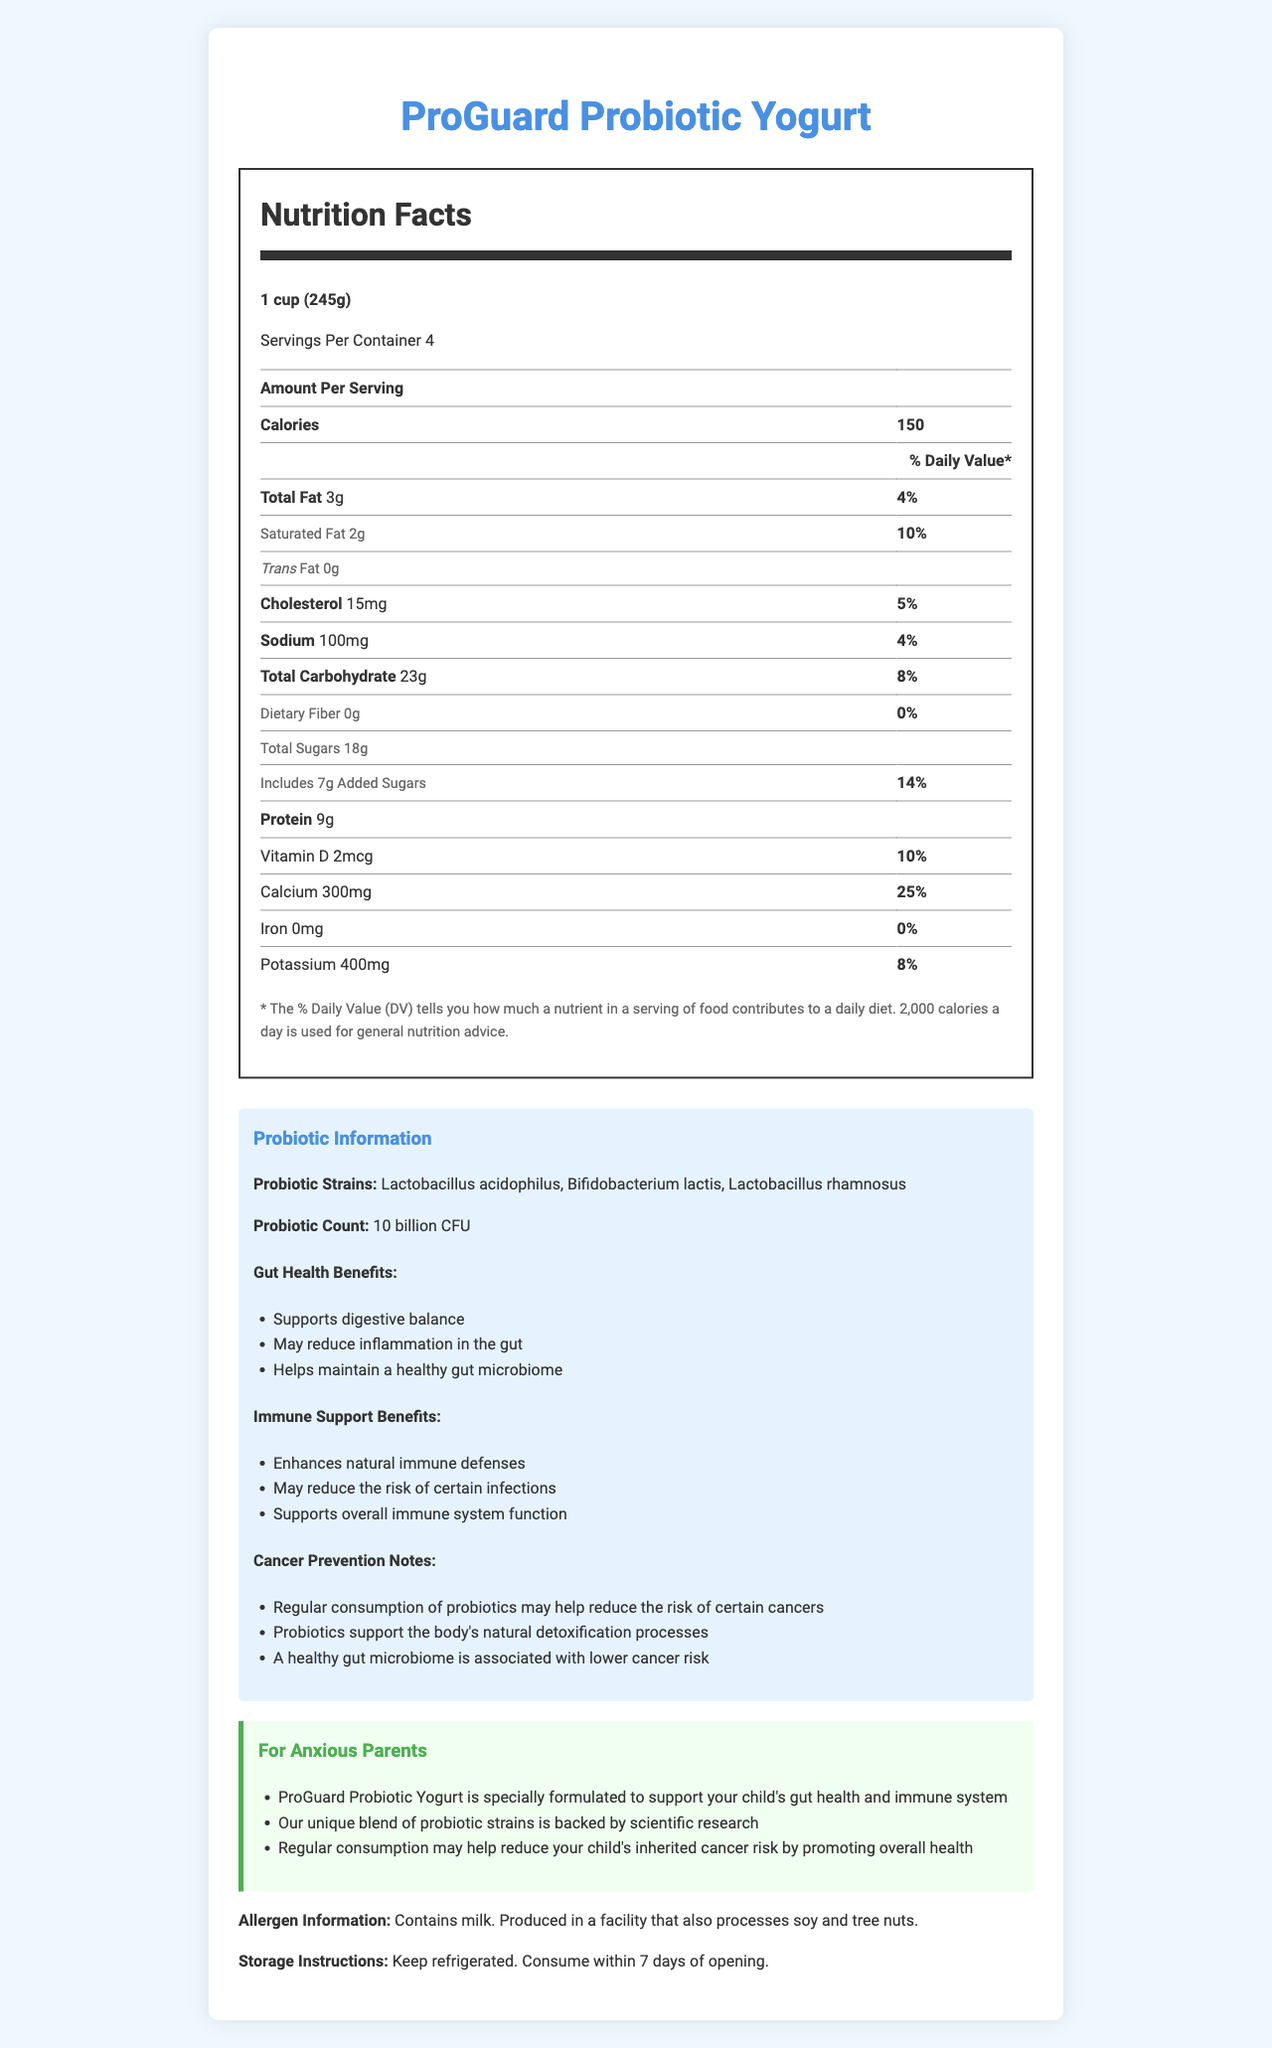what is the serving size of ProGuard Probiotic Yogurt? The serving size is mentioned at the beginning of the nutrition label as "1 cup (245g)".
Answer: 1 cup (245g) how many probiotic strains are present in this yogurt? The document lists three probiotic strains: Lactobacillus acidophilus, Bifidobacterium lactis, and Lactobacillus rhamnosus.
Answer: Three how much calcium is in one serving of the yogurt? The nutrition label mentions that each serving contains 300mg of calcium.
Answer: 300mg what are the allergen information provided for this product? The allergen information is listed at the end of the document stating it contains milk and is produced in a facility that processes soy and tree nuts.
Answer: Contains milk. Produced in a facility that also processes soy and tree nuts. What are the storage instructions for the yogurt? The storage instructions are clearly listed near the end of the document.
Answer: Keep refrigerated. Consume within 7 days of opening. How many calories are in one serving of ProGuard Probiotic Yogurt? A. 100 B. 150 C. 200 D. 250 The nutrition label states that each serving contains 150 calories.
Answer: B What is the daily value percentage of iron per serving of this yogurt? A. 5% B. 10% C. 0% D. 25% The document states that the daily value percentage of iron per serving is 0%.
Answer: C Does this yogurt contain any trans fat? The document shows "Trans Fat 0g," meaning there is no trans fat.
Answer: No Is this yogurt beneficial for both gut health and immune system support? The document lists benefits for both gut health (supports digestive balance, may reduce inflammation) and immune system support (enhances natural immune defenses, supports overall immune system).
Answer: Yes Summarize the main benefits of consuming ProGuard Probiotic Yogurt. The document provides detailed benefits about how this yogurt supports both gut health and immune functions, potentially assisting in cancer prevention.
Answer: ProGuard Probiotic Yogurt supports digestive balance, may reduce gut inflammation, and helps maintain a healthy gut microbiome. It also enhances immune system defenses and may reduce the risk of certain infections. Additionally, it can support cancer prevention by promoting a healthy gut microbiome and the body’s natural detoxification processes. What are the potential benefits of probiotics for cancer prevention mentioned in the document? The document highlights that regular probiotic consumption may reduce cancer risk, supports detoxification, and a healthy gut is linked to lower cancer risk.
Answer: Regular consumption may help reduce cancer risk, supports detoxification processes, associated with lower cancer risk. How much added sugar is in one serving of this yogurt? The nutrition label specifies that each serving includes 7g of added sugars.
Answer: 7g Can you determine the exact manufacturing date of the yogurt from this document? The document does not provide any information about the manufacturing date of the yogurt.
Answer: Not enough information What is the documented best advantage of consuming ProGuard Probiotic Yogurt for an anxious parent? A. It's very tasty. B. It has fewer calories. C. It supports your child's gut health and immune system. D. It has no added sugar. The reassurance section for anxious parents highlights the benefit of supporting a child’s gut health and immune system.
Answer: C 